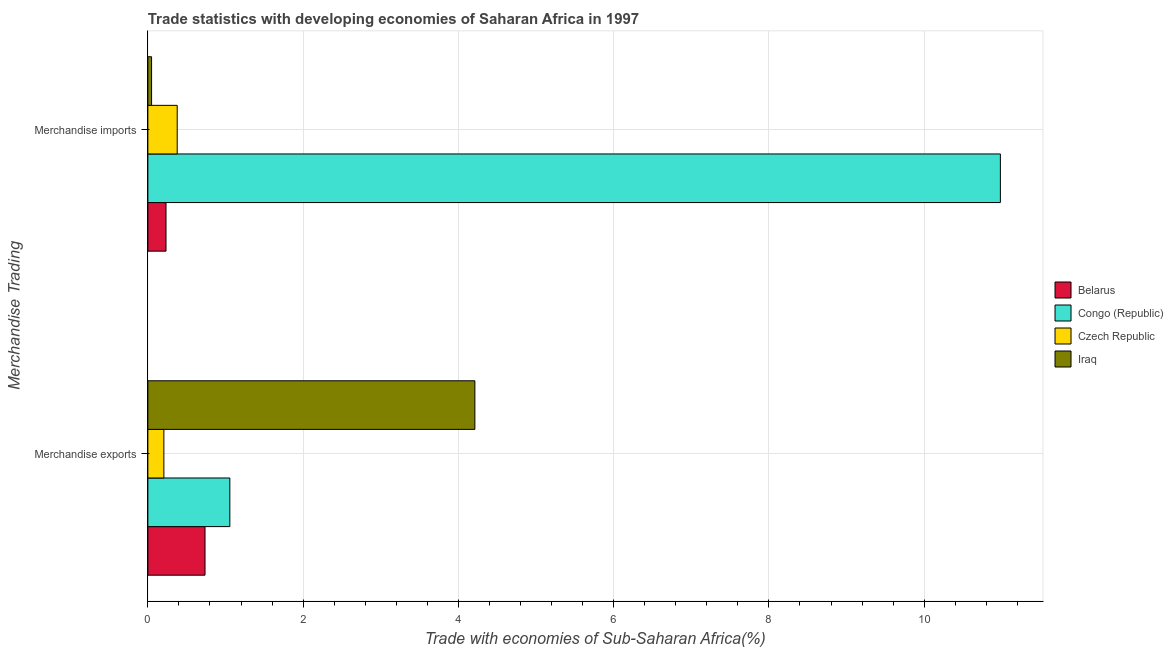How many bars are there on the 1st tick from the top?
Give a very brief answer. 4. How many bars are there on the 1st tick from the bottom?
Keep it short and to the point. 4. What is the label of the 1st group of bars from the top?
Offer a very short reply. Merchandise imports. What is the merchandise imports in Iraq?
Provide a succinct answer. 0.05. Across all countries, what is the maximum merchandise exports?
Ensure brevity in your answer.  4.21. Across all countries, what is the minimum merchandise exports?
Ensure brevity in your answer.  0.21. In which country was the merchandise imports maximum?
Your answer should be compact. Congo (Republic). In which country was the merchandise exports minimum?
Ensure brevity in your answer.  Czech Republic. What is the total merchandise imports in the graph?
Offer a very short reply. 11.64. What is the difference between the merchandise exports in Iraq and that in Belarus?
Make the answer very short. 3.48. What is the difference between the merchandise imports in Iraq and the merchandise exports in Congo (Republic)?
Your response must be concise. -1.01. What is the average merchandise imports per country?
Your response must be concise. 2.91. What is the difference between the merchandise exports and merchandise imports in Czech Republic?
Keep it short and to the point. -0.17. What is the ratio of the merchandise exports in Congo (Republic) to that in Iraq?
Your answer should be very brief. 0.25. Is the merchandise exports in Congo (Republic) less than that in Czech Republic?
Make the answer very short. No. What does the 4th bar from the top in Merchandise imports represents?
Give a very brief answer. Belarus. What does the 4th bar from the bottom in Merchandise exports represents?
Offer a terse response. Iraq. Are all the bars in the graph horizontal?
Your answer should be compact. Yes. What is the difference between two consecutive major ticks on the X-axis?
Your response must be concise. 2. Does the graph contain grids?
Provide a succinct answer. Yes. How many legend labels are there?
Your answer should be very brief. 4. How are the legend labels stacked?
Make the answer very short. Vertical. What is the title of the graph?
Make the answer very short. Trade statistics with developing economies of Saharan Africa in 1997. What is the label or title of the X-axis?
Your response must be concise. Trade with economies of Sub-Saharan Africa(%). What is the label or title of the Y-axis?
Make the answer very short. Merchandise Trading. What is the Trade with economies of Sub-Saharan Africa(%) of Belarus in Merchandise exports?
Your answer should be very brief. 0.74. What is the Trade with economies of Sub-Saharan Africa(%) of Congo (Republic) in Merchandise exports?
Keep it short and to the point. 1.06. What is the Trade with economies of Sub-Saharan Africa(%) of Czech Republic in Merchandise exports?
Ensure brevity in your answer.  0.21. What is the Trade with economies of Sub-Saharan Africa(%) of Iraq in Merchandise exports?
Offer a very short reply. 4.21. What is the Trade with economies of Sub-Saharan Africa(%) of Belarus in Merchandise imports?
Your answer should be compact. 0.23. What is the Trade with economies of Sub-Saharan Africa(%) of Congo (Republic) in Merchandise imports?
Provide a short and direct response. 10.98. What is the Trade with economies of Sub-Saharan Africa(%) in Czech Republic in Merchandise imports?
Your answer should be very brief. 0.38. What is the Trade with economies of Sub-Saharan Africa(%) of Iraq in Merchandise imports?
Your response must be concise. 0.05. Across all Merchandise Trading, what is the maximum Trade with economies of Sub-Saharan Africa(%) of Belarus?
Keep it short and to the point. 0.74. Across all Merchandise Trading, what is the maximum Trade with economies of Sub-Saharan Africa(%) in Congo (Republic)?
Your answer should be compact. 10.98. Across all Merchandise Trading, what is the maximum Trade with economies of Sub-Saharan Africa(%) in Czech Republic?
Ensure brevity in your answer.  0.38. Across all Merchandise Trading, what is the maximum Trade with economies of Sub-Saharan Africa(%) of Iraq?
Your response must be concise. 4.21. Across all Merchandise Trading, what is the minimum Trade with economies of Sub-Saharan Africa(%) of Belarus?
Your answer should be very brief. 0.23. Across all Merchandise Trading, what is the minimum Trade with economies of Sub-Saharan Africa(%) of Congo (Republic)?
Provide a succinct answer. 1.06. Across all Merchandise Trading, what is the minimum Trade with economies of Sub-Saharan Africa(%) in Czech Republic?
Provide a succinct answer. 0.21. Across all Merchandise Trading, what is the minimum Trade with economies of Sub-Saharan Africa(%) of Iraq?
Ensure brevity in your answer.  0.05. What is the total Trade with economies of Sub-Saharan Africa(%) of Belarus in the graph?
Ensure brevity in your answer.  0.97. What is the total Trade with economies of Sub-Saharan Africa(%) of Congo (Republic) in the graph?
Your answer should be very brief. 12.04. What is the total Trade with economies of Sub-Saharan Africa(%) of Czech Republic in the graph?
Your response must be concise. 0.58. What is the total Trade with economies of Sub-Saharan Africa(%) in Iraq in the graph?
Give a very brief answer. 4.26. What is the difference between the Trade with economies of Sub-Saharan Africa(%) in Belarus in Merchandise exports and that in Merchandise imports?
Provide a succinct answer. 0.5. What is the difference between the Trade with economies of Sub-Saharan Africa(%) of Congo (Republic) in Merchandise exports and that in Merchandise imports?
Give a very brief answer. -9.93. What is the difference between the Trade with economies of Sub-Saharan Africa(%) in Czech Republic in Merchandise exports and that in Merchandise imports?
Give a very brief answer. -0.17. What is the difference between the Trade with economies of Sub-Saharan Africa(%) in Iraq in Merchandise exports and that in Merchandise imports?
Provide a short and direct response. 4.16. What is the difference between the Trade with economies of Sub-Saharan Africa(%) in Belarus in Merchandise exports and the Trade with economies of Sub-Saharan Africa(%) in Congo (Republic) in Merchandise imports?
Provide a short and direct response. -10.25. What is the difference between the Trade with economies of Sub-Saharan Africa(%) in Belarus in Merchandise exports and the Trade with economies of Sub-Saharan Africa(%) in Czech Republic in Merchandise imports?
Keep it short and to the point. 0.36. What is the difference between the Trade with economies of Sub-Saharan Africa(%) of Belarus in Merchandise exports and the Trade with economies of Sub-Saharan Africa(%) of Iraq in Merchandise imports?
Your answer should be compact. 0.69. What is the difference between the Trade with economies of Sub-Saharan Africa(%) in Congo (Republic) in Merchandise exports and the Trade with economies of Sub-Saharan Africa(%) in Czech Republic in Merchandise imports?
Make the answer very short. 0.68. What is the difference between the Trade with economies of Sub-Saharan Africa(%) of Congo (Republic) in Merchandise exports and the Trade with economies of Sub-Saharan Africa(%) of Iraq in Merchandise imports?
Offer a terse response. 1.01. What is the difference between the Trade with economies of Sub-Saharan Africa(%) of Czech Republic in Merchandise exports and the Trade with economies of Sub-Saharan Africa(%) of Iraq in Merchandise imports?
Give a very brief answer. 0.16. What is the average Trade with economies of Sub-Saharan Africa(%) in Belarus per Merchandise Trading?
Your answer should be very brief. 0.48. What is the average Trade with economies of Sub-Saharan Africa(%) of Congo (Republic) per Merchandise Trading?
Keep it short and to the point. 6.02. What is the average Trade with economies of Sub-Saharan Africa(%) of Czech Republic per Merchandise Trading?
Make the answer very short. 0.29. What is the average Trade with economies of Sub-Saharan Africa(%) of Iraq per Merchandise Trading?
Your answer should be compact. 2.13. What is the difference between the Trade with economies of Sub-Saharan Africa(%) in Belarus and Trade with economies of Sub-Saharan Africa(%) in Congo (Republic) in Merchandise exports?
Ensure brevity in your answer.  -0.32. What is the difference between the Trade with economies of Sub-Saharan Africa(%) in Belarus and Trade with economies of Sub-Saharan Africa(%) in Czech Republic in Merchandise exports?
Your answer should be compact. 0.53. What is the difference between the Trade with economies of Sub-Saharan Africa(%) of Belarus and Trade with economies of Sub-Saharan Africa(%) of Iraq in Merchandise exports?
Offer a terse response. -3.48. What is the difference between the Trade with economies of Sub-Saharan Africa(%) of Congo (Republic) and Trade with economies of Sub-Saharan Africa(%) of Czech Republic in Merchandise exports?
Give a very brief answer. 0.85. What is the difference between the Trade with economies of Sub-Saharan Africa(%) of Congo (Republic) and Trade with economies of Sub-Saharan Africa(%) of Iraq in Merchandise exports?
Your answer should be compact. -3.16. What is the difference between the Trade with economies of Sub-Saharan Africa(%) in Czech Republic and Trade with economies of Sub-Saharan Africa(%) in Iraq in Merchandise exports?
Make the answer very short. -4.01. What is the difference between the Trade with economies of Sub-Saharan Africa(%) of Belarus and Trade with economies of Sub-Saharan Africa(%) of Congo (Republic) in Merchandise imports?
Make the answer very short. -10.75. What is the difference between the Trade with economies of Sub-Saharan Africa(%) in Belarus and Trade with economies of Sub-Saharan Africa(%) in Czech Republic in Merchandise imports?
Your answer should be very brief. -0.14. What is the difference between the Trade with economies of Sub-Saharan Africa(%) of Belarus and Trade with economies of Sub-Saharan Africa(%) of Iraq in Merchandise imports?
Keep it short and to the point. 0.19. What is the difference between the Trade with economies of Sub-Saharan Africa(%) of Congo (Republic) and Trade with economies of Sub-Saharan Africa(%) of Czech Republic in Merchandise imports?
Offer a very short reply. 10.6. What is the difference between the Trade with economies of Sub-Saharan Africa(%) of Congo (Republic) and Trade with economies of Sub-Saharan Africa(%) of Iraq in Merchandise imports?
Ensure brevity in your answer.  10.93. What is the difference between the Trade with economies of Sub-Saharan Africa(%) in Czech Republic and Trade with economies of Sub-Saharan Africa(%) in Iraq in Merchandise imports?
Ensure brevity in your answer.  0.33. What is the ratio of the Trade with economies of Sub-Saharan Africa(%) in Belarus in Merchandise exports to that in Merchandise imports?
Your answer should be compact. 3.15. What is the ratio of the Trade with economies of Sub-Saharan Africa(%) in Congo (Republic) in Merchandise exports to that in Merchandise imports?
Give a very brief answer. 0.1. What is the ratio of the Trade with economies of Sub-Saharan Africa(%) in Czech Republic in Merchandise exports to that in Merchandise imports?
Your response must be concise. 0.55. What is the ratio of the Trade with economies of Sub-Saharan Africa(%) in Iraq in Merchandise exports to that in Merchandise imports?
Your answer should be compact. 87.98. What is the difference between the highest and the second highest Trade with economies of Sub-Saharan Africa(%) in Belarus?
Offer a very short reply. 0.5. What is the difference between the highest and the second highest Trade with economies of Sub-Saharan Africa(%) of Congo (Republic)?
Your answer should be compact. 9.93. What is the difference between the highest and the second highest Trade with economies of Sub-Saharan Africa(%) of Czech Republic?
Your answer should be very brief. 0.17. What is the difference between the highest and the second highest Trade with economies of Sub-Saharan Africa(%) in Iraq?
Provide a succinct answer. 4.16. What is the difference between the highest and the lowest Trade with economies of Sub-Saharan Africa(%) in Belarus?
Keep it short and to the point. 0.5. What is the difference between the highest and the lowest Trade with economies of Sub-Saharan Africa(%) in Congo (Republic)?
Give a very brief answer. 9.93. What is the difference between the highest and the lowest Trade with economies of Sub-Saharan Africa(%) of Czech Republic?
Your answer should be compact. 0.17. What is the difference between the highest and the lowest Trade with economies of Sub-Saharan Africa(%) in Iraq?
Your answer should be very brief. 4.16. 